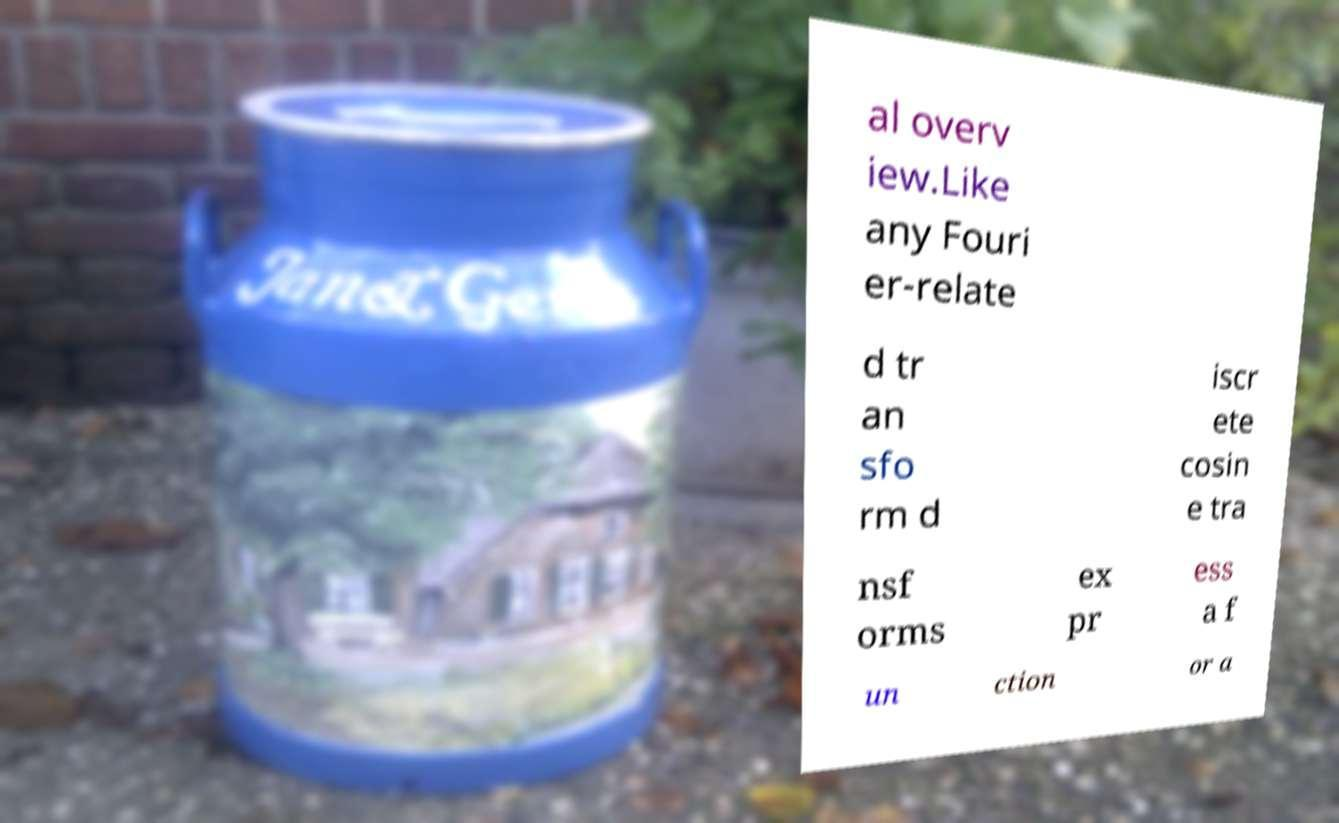There's text embedded in this image that I need extracted. Can you transcribe it verbatim? al overv iew.Like any Fouri er-relate d tr an sfo rm d iscr ete cosin e tra nsf orms ex pr ess a f un ction or a 